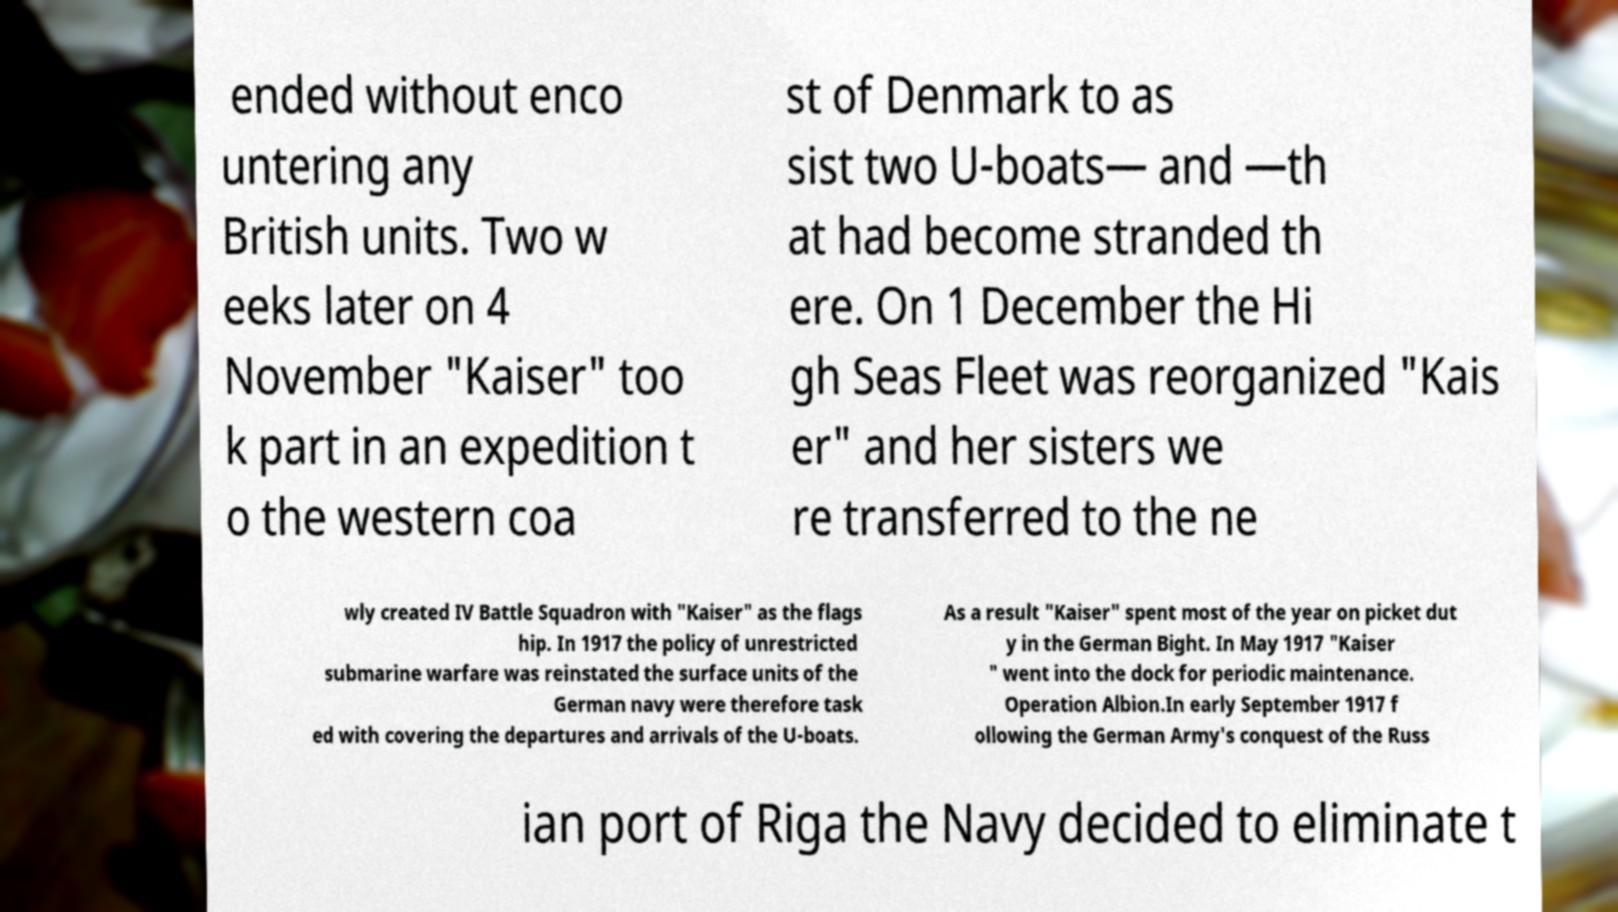Could you assist in decoding the text presented in this image and type it out clearly? ended without enco untering any British units. Two w eeks later on 4 November "Kaiser" too k part in an expedition t o the western coa st of Denmark to as sist two U-boats— and —th at had become stranded th ere. On 1 December the Hi gh Seas Fleet was reorganized "Kais er" and her sisters we re transferred to the ne wly created IV Battle Squadron with "Kaiser" as the flags hip. In 1917 the policy of unrestricted submarine warfare was reinstated the surface units of the German navy were therefore task ed with covering the departures and arrivals of the U-boats. As a result "Kaiser" spent most of the year on picket dut y in the German Bight. In May 1917 "Kaiser " went into the dock for periodic maintenance. Operation Albion.In early September 1917 f ollowing the German Army's conquest of the Russ ian port of Riga the Navy decided to eliminate t 